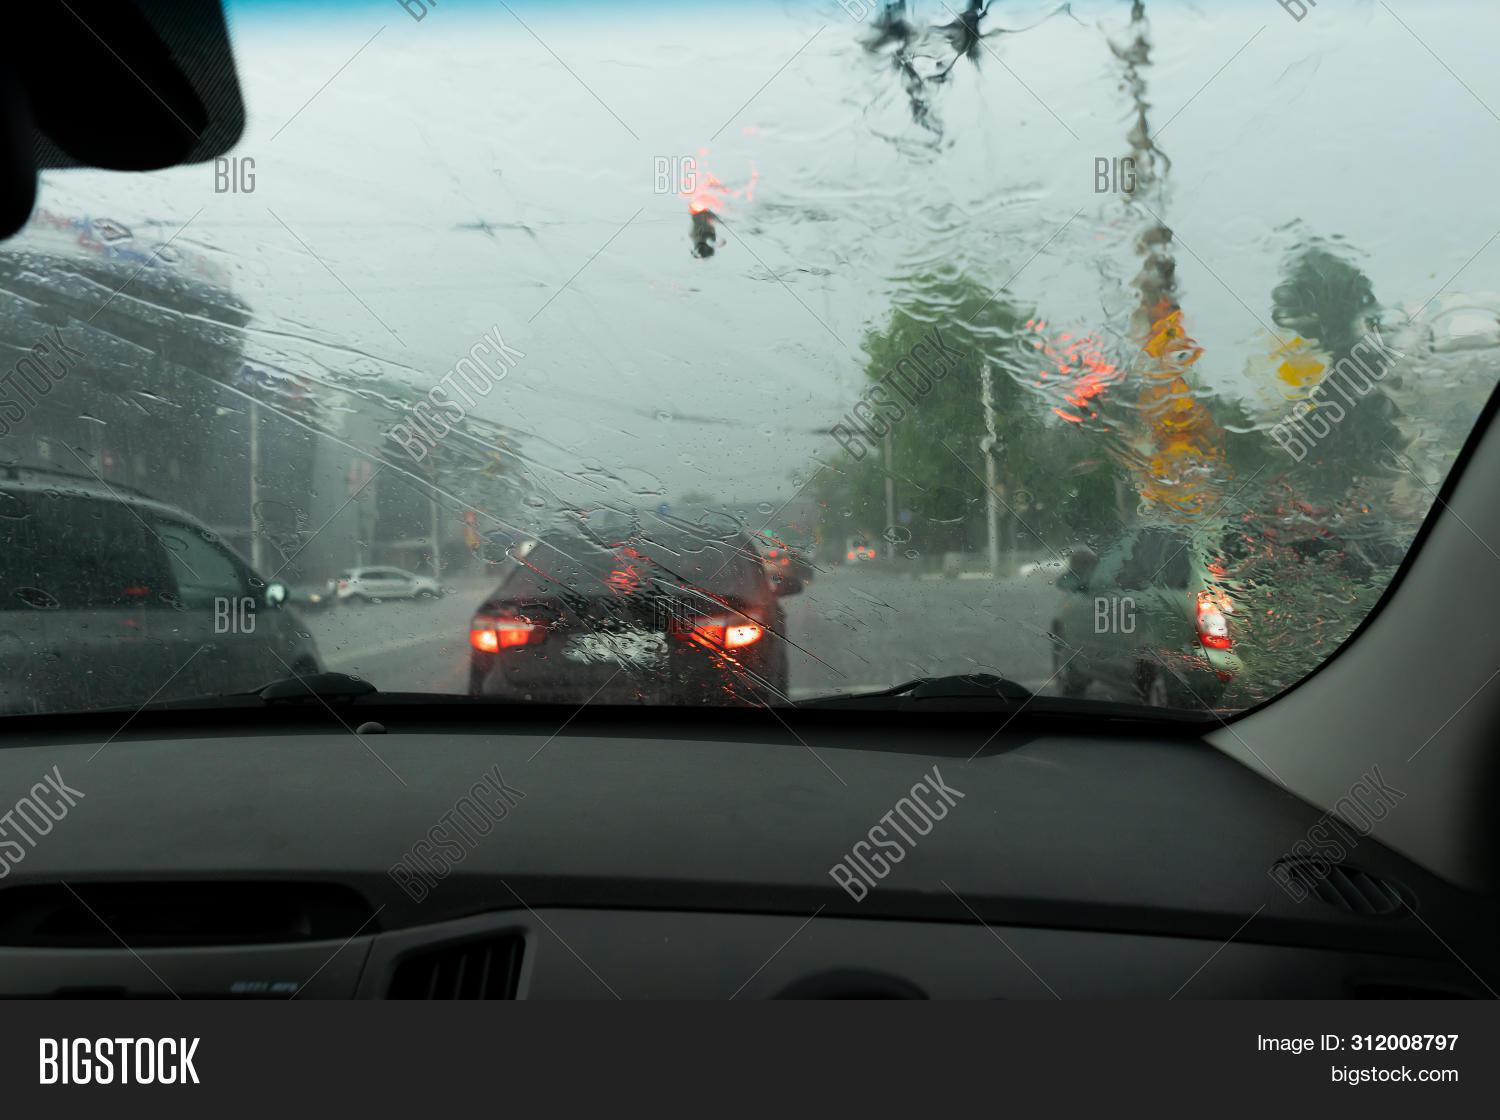How many cars are there in the image? In the image, I can see the tail lights of at least four cars through a rain-spattered windshield, suggesting a gloomy, overcast day on a busy street, as we wait for the traffic to move ahead. 